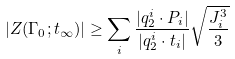<formula> <loc_0><loc_0><loc_500><loc_500>| Z ( \Gamma _ { 0 } ; t _ { \infty } ) | \geq \sum _ { i } \frac { | q _ { 2 } ^ { i } \cdot P _ { i } | } { | q _ { 2 } ^ { i } \cdot t _ { i } | } \sqrt { \frac { J _ { i } ^ { 3 } } { 3 } }</formula> 